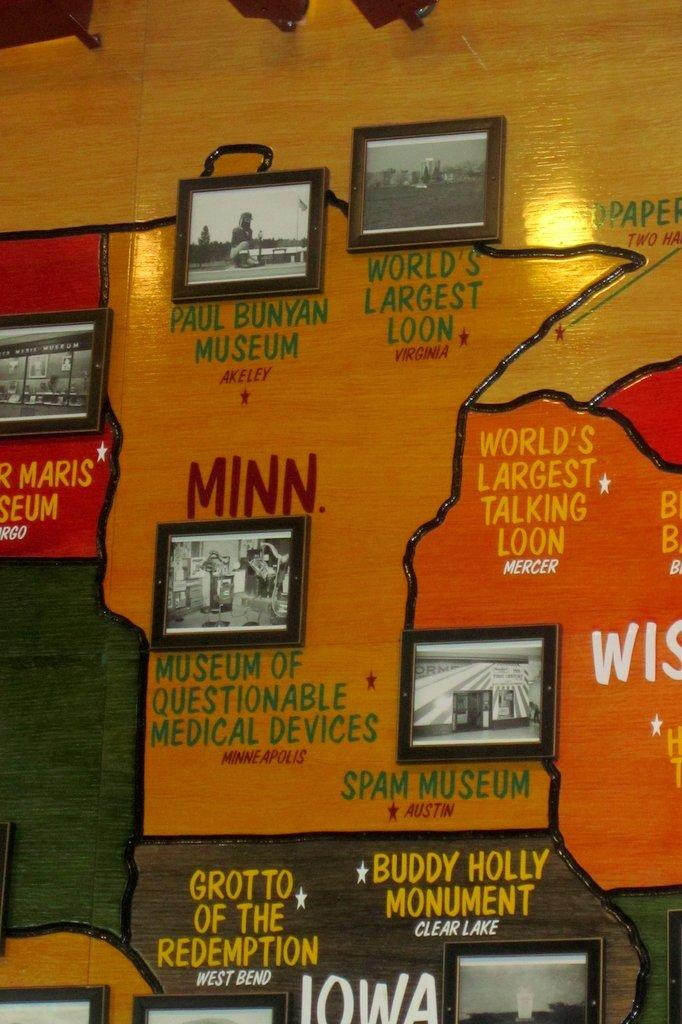<image>
Render a clear and concise summary of the photo. a wall that says 'world's largest talking loon' on it 